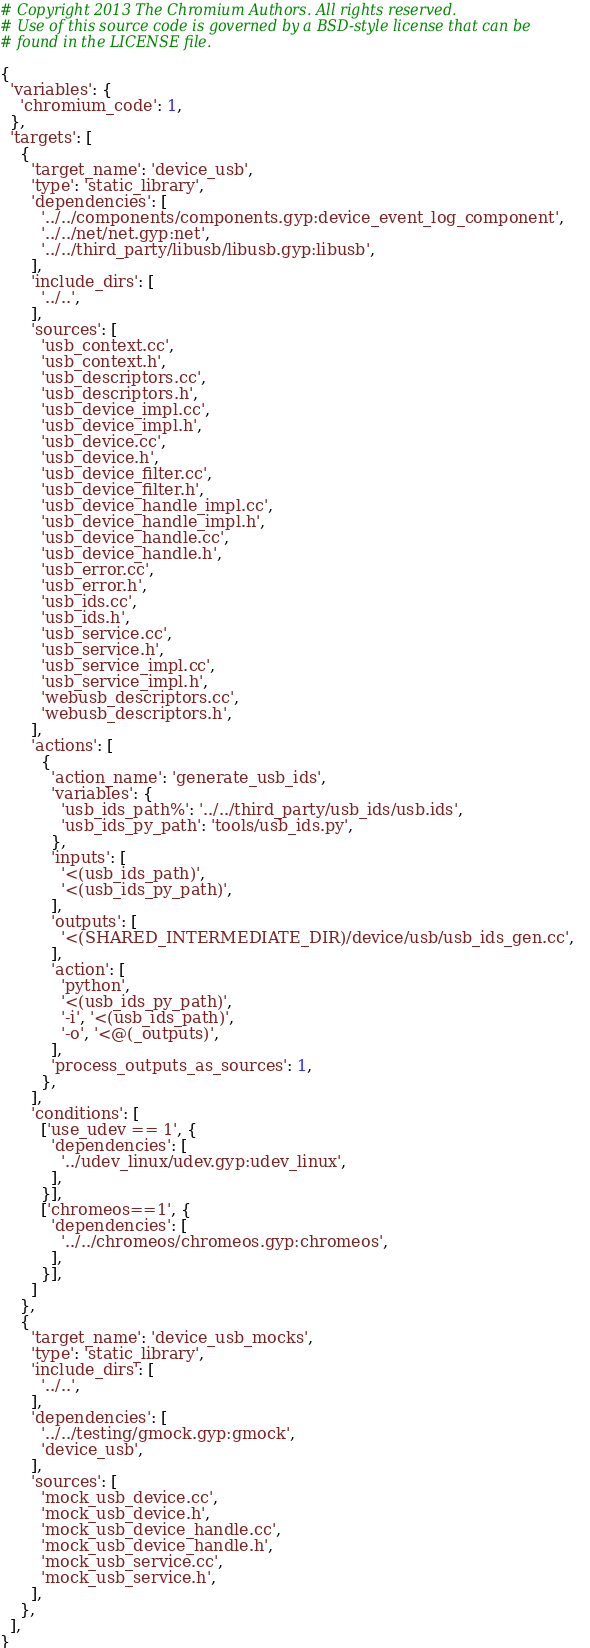Convert code to text. <code><loc_0><loc_0><loc_500><loc_500><_Python_># Copyright 2013 The Chromium Authors. All rights reserved.
# Use of this source code is governed by a BSD-style license that can be
# found in the LICENSE file.

{
  'variables': {
    'chromium_code': 1,
  },
  'targets': [
    {
      'target_name': 'device_usb',
      'type': 'static_library',
      'dependencies': [
        '../../components/components.gyp:device_event_log_component',
        '../../net/net.gyp:net',
        '../../third_party/libusb/libusb.gyp:libusb',
      ],
      'include_dirs': [
        '../..',
      ],
      'sources': [
        'usb_context.cc',
        'usb_context.h',
        'usb_descriptors.cc',
        'usb_descriptors.h',
        'usb_device_impl.cc',
        'usb_device_impl.h',
        'usb_device.cc',
        'usb_device.h',
        'usb_device_filter.cc',
        'usb_device_filter.h',
        'usb_device_handle_impl.cc',
        'usb_device_handle_impl.h',
        'usb_device_handle.cc',
        'usb_device_handle.h',
        'usb_error.cc',
        'usb_error.h',
        'usb_ids.cc',
        'usb_ids.h',
        'usb_service.cc',
        'usb_service.h',
        'usb_service_impl.cc',
        'usb_service_impl.h',
        'webusb_descriptors.cc',
        'webusb_descriptors.h',
      ],
      'actions': [
        {
          'action_name': 'generate_usb_ids',
          'variables': {
            'usb_ids_path%': '../../third_party/usb_ids/usb.ids',
            'usb_ids_py_path': 'tools/usb_ids.py',
          },
          'inputs': [
            '<(usb_ids_path)',
            '<(usb_ids_py_path)',
          ],
          'outputs': [
            '<(SHARED_INTERMEDIATE_DIR)/device/usb/usb_ids_gen.cc',
          ],
          'action': [
            'python',
            '<(usb_ids_py_path)',
            '-i', '<(usb_ids_path)',
            '-o', '<@(_outputs)',
          ],
          'process_outputs_as_sources': 1,
        },
      ],
      'conditions': [
        ['use_udev == 1', {
          'dependencies': [
            '../udev_linux/udev.gyp:udev_linux',
          ],
        }],
        ['chromeos==1', {
          'dependencies': [
            '../../chromeos/chromeos.gyp:chromeos',
          ],
        }],
      ]
    },
    {
      'target_name': 'device_usb_mocks',
      'type': 'static_library',
      'include_dirs': [
        '../..',
      ],
      'dependencies': [
        '../../testing/gmock.gyp:gmock',
        'device_usb',
      ],
      'sources': [
        'mock_usb_device.cc',
        'mock_usb_device.h',
        'mock_usb_device_handle.cc',
        'mock_usb_device_handle.h',
        'mock_usb_service.cc',
        'mock_usb_service.h',
      ],
    },
  ],
}
</code> 